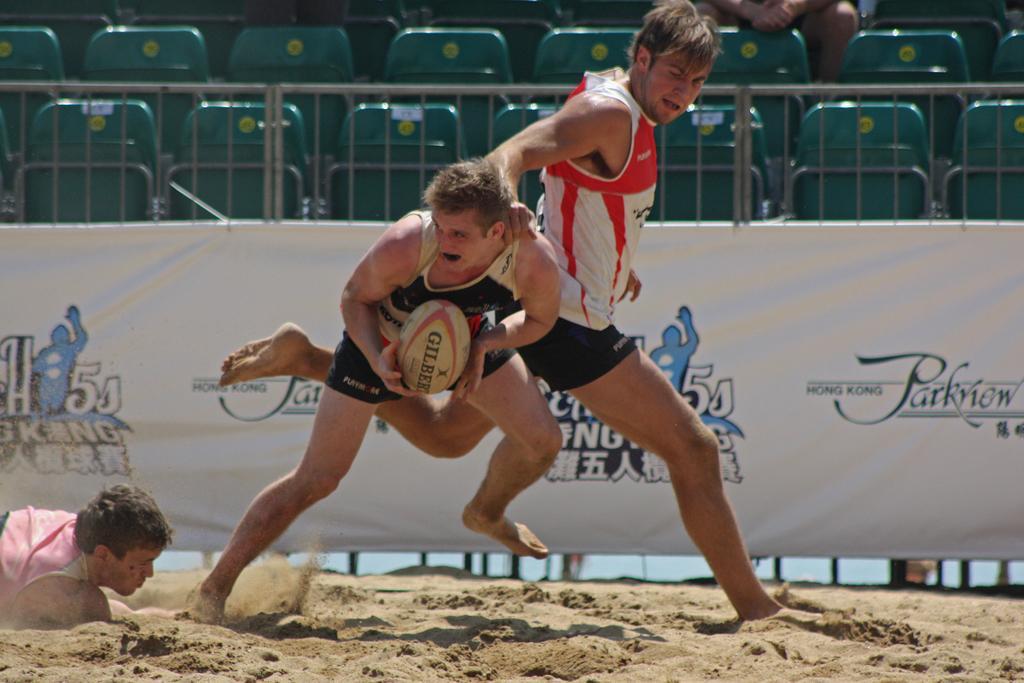Describe this image in one or two sentences. In the foreground of the picture there are people playing rugby. At the bottom there is sand. In the center of the background there is a banner to the railing. At the top there are cars, there is a person sitting in a chair. 